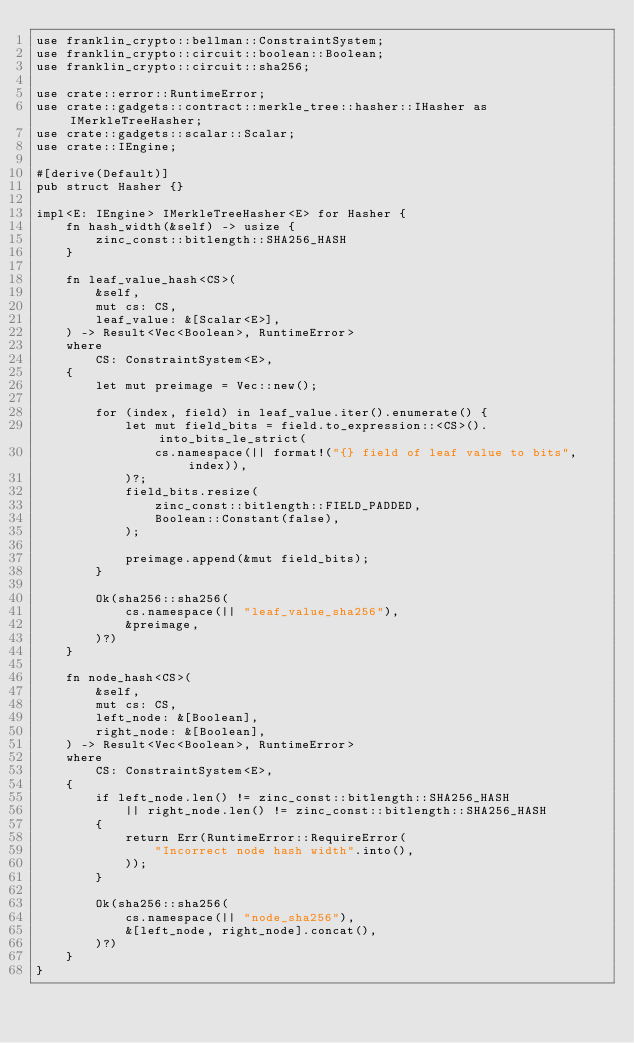Convert code to text. <code><loc_0><loc_0><loc_500><loc_500><_Rust_>use franklin_crypto::bellman::ConstraintSystem;
use franklin_crypto::circuit::boolean::Boolean;
use franklin_crypto::circuit::sha256;

use crate::error::RuntimeError;
use crate::gadgets::contract::merkle_tree::hasher::IHasher as IMerkleTreeHasher;
use crate::gadgets::scalar::Scalar;
use crate::IEngine;

#[derive(Default)]
pub struct Hasher {}

impl<E: IEngine> IMerkleTreeHasher<E> for Hasher {
    fn hash_width(&self) -> usize {
        zinc_const::bitlength::SHA256_HASH
    }

    fn leaf_value_hash<CS>(
        &self,
        mut cs: CS,
        leaf_value: &[Scalar<E>],
    ) -> Result<Vec<Boolean>, RuntimeError>
    where
        CS: ConstraintSystem<E>,
    {
        let mut preimage = Vec::new();

        for (index, field) in leaf_value.iter().enumerate() {
            let mut field_bits = field.to_expression::<CS>().into_bits_le_strict(
                cs.namespace(|| format!("{} field of leaf value to bits", index)),
            )?;
            field_bits.resize(
                zinc_const::bitlength::FIELD_PADDED,
                Boolean::Constant(false),
            );

            preimage.append(&mut field_bits);
        }

        Ok(sha256::sha256(
            cs.namespace(|| "leaf_value_sha256"),
            &preimage,
        )?)
    }

    fn node_hash<CS>(
        &self,
        mut cs: CS,
        left_node: &[Boolean],
        right_node: &[Boolean],
    ) -> Result<Vec<Boolean>, RuntimeError>
    where
        CS: ConstraintSystem<E>,
    {
        if left_node.len() != zinc_const::bitlength::SHA256_HASH
            || right_node.len() != zinc_const::bitlength::SHA256_HASH
        {
            return Err(RuntimeError::RequireError(
                "Incorrect node hash width".into(),
            ));
        }

        Ok(sha256::sha256(
            cs.namespace(|| "node_sha256"),
            &[left_node, right_node].concat(),
        )?)
    }
}
</code> 